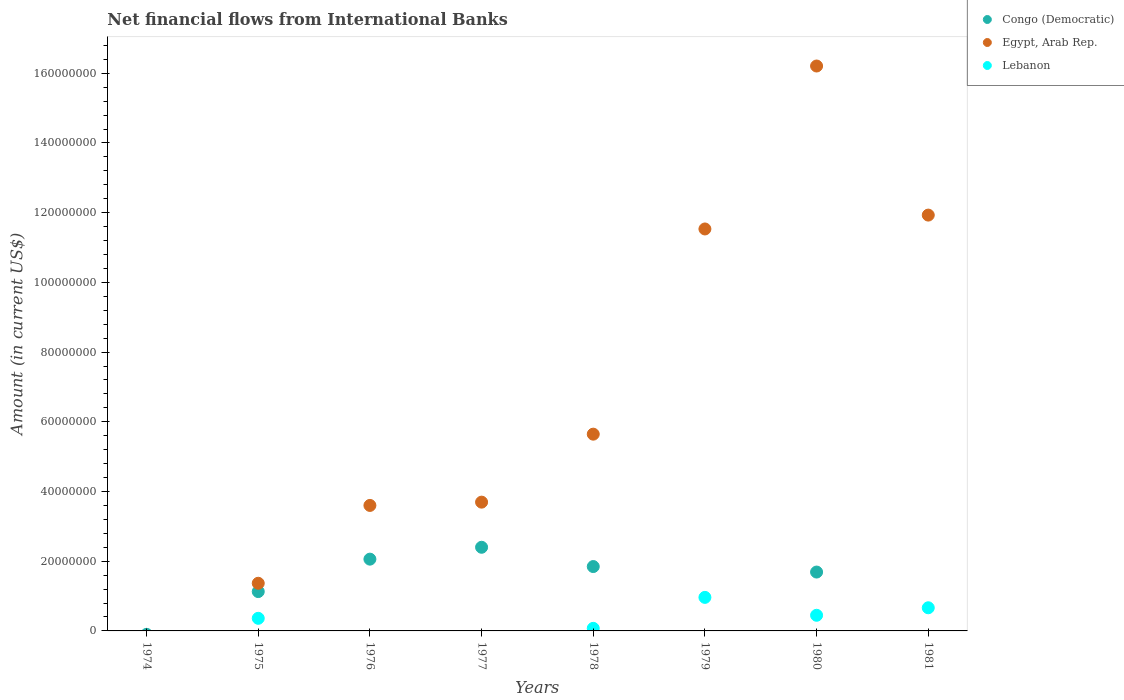Is the number of dotlines equal to the number of legend labels?
Give a very brief answer. No. What is the net financial aid flows in Egypt, Arab Rep. in 1980?
Make the answer very short. 1.62e+08. Across all years, what is the maximum net financial aid flows in Congo (Democratic)?
Make the answer very short. 2.40e+07. In which year was the net financial aid flows in Lebanon maximum?
Provide a short and direct response. 1979. What is the total net financial aid flows in Lebanon in the graph?
Make the answer very short. 2.51e+07. What is the difference between the net financial aid flows in Lebanon in 1978 and that in 1980?
Provide a short and direct response. -3.75e+06. What is the difference between the net financial aid flows in Lebanon in 1975 and the net financial aid flows in Egypt, Arab Rep. in 1974?
Keep it short and to the point. 3.62e+06. What is the average net financial aid flows in Congo (Democratic) per year?
Keep it short and to the point. 1.14e+07. In the year 1978, what is the difference between the net financial aid flows in Lebanon and net financial aid flows in Congo (Democratic)?
Your answer should be compact. -1.77e+07. What is the ratio of the net financial aid flows in Egypt, Arab Rep. in 1976 to that in 1981?
Your answer should be compact. 0.3. Is the net financial aid flows in Egypt, Arab Rep. in 1976 less than that in 1981?
Provide a succinct answer. Yes. Is the difference between the net financial aid flows in Lebanon in 1975 and 1980 greater than the difference between the net financial aid flows in Congo (Democratic) in 1975 and 1980?
Give a very brief answer. Yes. What is the difference between the highest and the second highest net financial aid flows in Egypt, Arab Rep.?
Your answer should be very brief. 4.28e+07. What is the difference between the highest and the lowest net financial aid flows in Congo (Democratic)?
Make the answer very short. 2.40e+07. Is the sum of the net financial aid flows in Congo (Democratic) in 1976 and 1977 greater than the maximum net financial aid flows in Lebanon across all years?
Ensure brevity in your answer.  Yes. How many years are there in the graph?
Keep it short and to the point. 8. Does the graph contain any zero values?
Keep it short and to the point. Yes. Does the graph contain grids?
Provide a succinct answer. No. How many legend labels are there?
Keep it short and to the point. 3. What is the title of the graph?
Offer a terse response. Net financial flows from International Banks. Does "Latin America(developing only)" appear as one of the legend labels in the graph?
Provide a succinct answer. No. What is the label or title of the X-axis?
Offer a very short reply. Years. What is the label or title of the Y-axis?
Offer a very short reply. Amount (in current US$). What is the Amount (in current US$) in Congo (Democratic) in 1974?
Give a very brief answer. 0. What is the Amount (in current US$) in Egypt, Arab Rep. in 1974?
Make the answer very short. 0. What is the Amount (in current US$) of Congo (Democratic) in 1975?
Your answer should be compact. 1.13e+07. What is the Amount (in current US$) of Egypt, Arab Rep. in 1975?
Make the answer very short. 1.37e+07. What is the Amount (in current US$) in Lebanon in 1975?
Give a very brief answer. 3.62e+06. What is the Amount (in current US$) of Congo (Democratic) in 1976?
Your answer should be compact. 2.06e+07. What is the Amount (in current US$) of Egypt, Arab Rep. in 1976?
Provide a succinct answer. 3.60e+07. What is the Amount (in current US$) in Congo (Democratic) in 1977?
Provide a short and direct response. 2.40e+07. What is the Amount (in current US$) in Egypt, Arab Rep. in 1977?
Give a very brief answer. 3.69e+07. What is the Amount (in current US$) in Lebanon in 1977?
Offer a terse response. 0. What is the Amount (in current US$) in Congo (Democratic) in 1978?
Offer a very short reply. 1.85e+07. What is the Amount (in current US$) in Egypt, Arab Rep. in 1978?
Give a very brief answer. 5.65e+07. What is the Amount (in current US$) of Lebanon in 1978?
Your answer should be compact. 7.38e+05. What is the Amount (in current US$) in Congo (Democratic) in 1979?
Offer a terse response. 0. What is the Amount (in current US$) in Egypt, Arab Rep. in 1979?
Offer a terse response. 1.15e+08. What is the Amount (in current US$) in Lebanon in 1979?
Offer a terse response. 9.62e+06. What is the Amount (in current US$) in Congo (Democratic) in 1980?
Keep it short and to the point. 1.69e+07. What is the Amount (in current US$) in Egypt, Arab Rep. in 1980?
Your response must be concise. 1.62e+08. What is the Amount (in current US$) in Lebanon in 1980?
Offer a terse response. 4.49e+06. What is the Amount (in current US$) of Egypt, Arab Rep. in 1981?
Ensure brevity in your answer.  1.19e+08. What is the Amount (in current US$) of Lebanon in 1981?
Provide a short and direct response. 6.64e+06. Across all years, what is the maximum Amount (in current US$) in Congo (Democratic)?
Keep it short and to the point. 2.40e+07. Across all years, what is the maximum Amount (in current US$) in Egypt, Arab Rep.?
Give a very brief answer. 1.62e+08. Across all years, what is the maximum Amount (in current US$) of Lebanon?
Offer a terse response. 9.62e+06. Across all years, what is the minimum Amount (in current US$) of Congo (Democratic)?
Provide a succinct answer. 0. Across all years, what is the minimum Amount (in current US$) of Lebanon?
Give a very brief answer. 0. What is the total Amount (in current US$) in Congo (Democratic) in the graph?
Your answer should be very brief. 9.12e+07. What is the total Amount (in current US$) in Egypt, Arab Rep. in the graph?
Your response must be concise. 5.40e+08. What is the total Amount (in current US$) in Lebanon in the graph?
Your answer should be compact. 2.51e+07. What is the difference between the Amount (in current US$) in Congo (Democratic) in 1975 and that in 1976?
Your answer should be very brief. -9.30e+06. What is the difference between the Amount (in current US$) of Egypt, Arab Rep. in 1975 and that in 1976?
Ensure brevity in your answer.  -2.23e+07. What is the difference between the Amount (in current US$) of Congo (Democratic) in 1975 and that in 1977?
Give a very brief answer. -1.27e+07. What is the difference between the Amount (in current US$) of Egypt, Arab Rep. in 1975 and that in 1977?
Give a very brief answer. -2.33e+07. What is the difference between the Amount (in current US$) in Congo (Democratic) in 1975 and that in 1978?
Offer a terse response. -7.18e+06. What is the difference between the Amount (in current US$) in Egypt, Arab Rep. in 1975 and that in 1978?
Provide a short and direct response. -4.28e+07. What is the difference between the Amount (in current US$) in Lebanon in 1975 and that in 1978?
Keep it short and to the point. 2.88e+06. What is the difference between the Amount (in current US$) of Egypt, Arab Rep. in 1975 and that in 1979?
Provide a short and direct response. -1.02e+08. What is the difference between the Amount (in current US$) in Lebanon in 1975 and that in 1979?
Ensure brevity in your answer.  -6.00e+06. What is the difference between the Amount (in current US$) of Congo (Democratic) in 1975 and that in 1980?
Offer a terse response. -5.60e+06. What is the difference between the Amount (in current US$) of Egypt, Arab Rep. in 1975 and that in 1980?
Make the answer very short. -1.48e+08. What is the difference between the Amount (in current US$) of Lebanon in 1975 and that in 1980?
Your response must be concise. -8.71e+05. What is the difference between the Amount (in current US$) of Egypt, Arab Rep. in 1975 and that in 1981?
Offer a terse response. -1.06e+08. What is the difference between the Amount (in current US$) of Lebanon in 1975 and that in 1981?
Provide a succinct answer. -3.02e+06. What is the difference between the Amount (in current US$) of Congo (Democratic) in 1976 and that in 1977?
Your answer should be compact. -3.41e+06. What is the difference between the Amount (in current US$) of Egypt, Arab Rep. in 1976 and that in 1977?
Offer a very short reply. -9.43e+05. What is the difference between the Amount (in current US$) in Congo (Democratic) in 1976 and that in 1978?
Make the answer very short. 2.12e+06. What is the difference between the Amount (in current US$) in Egypt, Arab Rep. in 1976 and that in 1978?
Keep it short and to the point. -2.04e+07. What is the difference between the Amount (in current US$) of Egypt, Arab Rep. in 1976 and that in 1979?
Your answer should be very brief. -7.93e+07. What is the difference between the Amount (in current US$) in Congo (Democratic) in 1976 and that in 1980?
Offer a terse response. 3.70e+06. What is the difference between the Amount (in current US$) of Egypt, Arab Rep. in 1976 and that in 1980?
Provide a short and direct response. -1.26e+08. What is the difference between the Amount (in current US$) of Egypt, Arab Rep. in 1976 and that in 1981?
Offer a terse response. -8.33e+07. What is the difference between the Amount (in current US$) in Congo (Democratic) in 1977 and that in 1978?
Your answer should be compact. 5.53e+06. What is the difference between the Amount (in current US$) in Egypt, Arab Rep. in 1977 and that in 1978?
Give a very brief answer. -1.95e+07. What is the difference between the Amount (in current US$) in Egypt, Arab Rep. in 1977 and that in 1979?
Your response must be concise. -7.84e+07. What is the difference between the Amount (in current US$) of Congo (Democratic) in 1977 and that in 1980?
Offer a terse response. 7.11e+06. What is the difference between the Amount (in current US$) of Egypt, Arab Rep. in 1977 and that in 1980?
Give a very brief answer. -1.25e+08. What is the difference between the Amount (in current US$) in Egypt, Arab Rep. in 1977 and that in 1981?
Offer a terse response. -8.24e+07. What is the difference between the Amount (in current US$) in Egypt, Arab Rep. in 1978 and that in 1979?
Ensure brevity in your answer.  -5.89e+07. What is the difference between the Amount (in current US$) of Lebanon in 1978 and that in 1979?
Your answer should be compact. -8.88e+06. What is the difference between the Amount (in current US$) of Congo (Democratic) in 1978 and that in 1980?
Provide a short and direct response. 1.58e+06. What is the difference between the Amount (in current US$) of Egypt, Arab Rep. in 1978 and that in 1980?
Your response must be concise. -1.06e+08. What is the difference between the Amount (in current US$) of Lebanon in 1978 and that in 1980?
Keep it short and to the point. -3.75e+06. What is the difference between the Amount (in current US$) of Egypt, Arab Rep. in 1978 and that in 1981?
Provide a short and direct response. -6.29e+07. What is the difference between the Amount (in current US$) of Lebanon in 1978 and that in 1981?
Offer a terse response. -5.90e+06. What is the difference between the Amount (in current US$) of Egypt, Arab Rep. in 1979 and that in 1980?
Provide a short and direct response. -4.68e+07. What is the difference between the Amount (in current US$) in Lebanon in 1979 and that in 1980?
Your answer should be compact. 5.13e+06. What is the difference between the Amount (in current US$) in Egypt, Arab Rep. in 1979 and that in 1981?
Keep it short and to the point. -3.98e+06. What is the difference between the Amount (in current US$) in Lebanon in 1979 and that in 1981?
Make the answer very short. 2.98e+06. What is the difference between the Amount (in current US$) of Egypt, Arab Rep. in 1980 and that in 1981?
Make the answer very short. 4.28e+07. What is the difference between the Amount (in current US$) in Lebanon in 1980 and that in 1981?
Offer a terse response. -2.15e+06. What is the difference between the Amount (in current US$) in Congo (Democratic) in 1975 and the Amount (in current US$) in Egypt, Arab Rep. in 1976?
Your answer should be very brief. -2.47e+07. What is the difference between the Amount (in current US$) in Congo (Democratic) in 1975 and the Amount (in current US$) in Egypt, Arab Rep. in 1977?
Ensure brevity in your answer.  -2.57e+07. What is the difference between the Amount (in current US$) in Congo (Democratic) in 1975 and the Amount (in current US$) in Egypt, Arab Rep. in 1978?
Offer a terse response. -4.52e+07. What is the difference between the Amount (in current US$) in Congo (Democratic) in 1975 and the Amount (in current US$) in Lebanon in 1978?
Provide a succinct answer. 1.05e+07. What is the difference between the Amount (in current US$) of Egypt, Arab Rep. in 1975 and the Amount (in current US$) of Lebanon in 1978?
Provide a succinct answer. 1.29e+07. What is the difference between the Amount (in current US$) of Congo (Democratic) in 1975 and the Amount (in current US$) of Egypt, Arab Rep. in 1979?
Your response must be concise. -1.04e+08. What is the difference between the Amount (in current US$) in Congo (Democratic) in 1975 and the Amount (in current US$) in Lebanon in 1979?
Your answer should be very brief. 1.66e+06. What is the difference between the Amount (in current US$) in Egypt, Arab Rep. in 1975 and the Amount (in current US$) in Lebanon in 1979?
Offer a terse response. 4.05e+06. What is the difference between the Amount (in current US$) in Congo (Democratic) in 1975 and the Amount (in current US$) in Egypt, Arab Rep. in 1980?
Ensure brevity in your answer.  -1.51e+08. What is the difference between the Amount (in current US$) in Congo (Democratic) in 1975 and the Amount (in current US$) in Lebanon in 1980?
Ensure brevity in your answer.  6.80e+06. What is the difference between the Amount (in current US$) of Egypt, Arab Rep. in 1975 and the Amount (in current US$) of Lebanon in 1980?
Keep it short and to the point. 9.18e+06. What is the difference between the Amount (in current US$) in Congo (Democratic) in 1975 and the Amount (in current US$) in Egypt, Arab Rep. in 1981?
Offer a terse response. -1.08e+08. What is the difference between the Amount (in current US$) in Congo (Democratic) in 1975 and the Amount (in current US$) in Lebanon in 1981?
Your answer should be very brief. 4.64e+06. What is the difference between the Amount (in current US$) in Egypt, Arab Rep. in 1975 and the Amount (in current US$) in Lebanon in 1981?
Your answer should be very brief. 7.03e+06. What is the difference between the Amount (in current US$) of Congo (Democratic) in 1976 and the Amount (in current US$) of Egypt, Arab Rep. in 1977?
Ensure brevity in your answer.  -1.64e+07. What is the difference between the Amount (in current US$) of Congo (Democratic) in 1976 and the Amount (in current US$) of Egypt, Arab Rep. in 1978?
Keep it short and to the point. -3.59e+07. What is the difference between the Amount (in current US$) of Congo (Democratic) in 1976 and the Amount (in current US$) of Lebanon in 1978?
Give a very brief answer. 1.99e+07. What is the difference between the Amount (in current US$) in Egypt, Arab Rep. in 1976 and the Amount (in current US$) in Lebanon in 1978?
Keep it short and to the point. 3.53e+07. What is the difference between the Amount (in current US$) of Congo (Democratic) in 1976 and the Amount (in current US$) of Egypt, Arab Rep. in 1979?
Keep it short and to the point. -9.47e+07. What is the difference between the Amount (in current US$) of Congo (Democratic) in 1976 and the Amount (in current US$) of Lebanon in 1979?
Ensure brevity in your answer.  1.10e+07. What is the difference between the Amount (in current US$) of Egypt, Arab Rep. in 1976 and the Amount (in current US$) of Lebanon in 1979?
Offer a very short reply. 2.64e+07. What is the difference between the Amount (in current US$) in Congo (Democratic) in 1976 and the Amount (in current US$) in Egypt, Arab Rep. in 1980?
Provide a succinct answer. -1.41e+08. What is the difference between the Amount (in current US$) in Congo (Democratic) in 1976 and the Amount (in current US$) in Lebanon in 1980?
Make the answer very short. 1.61e+07. What is the difference between the Amount (in current US$) of Egypt, Arab Rep. in 1976 and the Amount (in current US$) of Lebanon in 1980?
Make the answer very short. 3.15e+07. What is the difference between the Amount (in current US$) in Congo (Democratic) in 1976 and the Amount (in current US$) in Egypt, Arab Rep. in 1981?
Give a very brief answer. -9.87e+07. What is the difference between the Amount (in current US$) of Congo (Democratic) in 1976 and the Amount (in current US$) of Lebanon in 1981?
Provide a short and direct response. 1.40e+07. What is the difference between the Amount (in current US$) in Egypt, Arab Rep. in 1976 and the Amount (in current US$) in Lebanon in 1981?
Provide a short and direct response. 2.94e+07. What is the difference between the Amount (in current US$) of Congo (Democratic) in 1977 and the Amount (in current US$) of Egypt, Arab Rep. in 1978?
Offer a terse response. -3.25e+07. What is the difference between the Amount (in current US$) of Congo (Democratic) in 1977 and the Amount (in current US$) of Lebanon in 1978?
Keep it short and to the point. 2.33e+07. What is the difference between the Amount (in current US$) in Egypt, Arab Rep. in 1977 and the Amount (in current US$) in Lebanon in 1978?
Give a very brief answer. 3.62e+07. What is the difference between the Amount (in current US$) of Congo (Democratic) in 1977 and the Amount (in current US$) of Egypt, Arab Rep. in 1979?
Make the answer very short. -9.13e+07. What is the difference between the Amount (in current US$) of Congo (Democratic) in 1977 and the Amount (in current US$) of Lebanon in 1979?
Your answer should be compact. 1.44e+07. What is the difference between the Amount (in current US$) in Egypt, Arab Rep. in 1977 and the Amount (in current US$) in Lebanon in 1979?
Your response must be concise. 2.73e+07. What is the difference between the Amount (in current US$) in Congo (Democratic) in 1977 and the Amount (in current US$) in Egypt, Arab Rep. in 1980?
Provide a short and direct response. -1.38e+08. What is the difference between the Amount (in current US$) in Congo (Democratic) in 1977 and the Amount (in current US$) in Lebanon in 1980?
Make the answer very short. 1.95e+07. What is the difference between the Amount (in current US$) of Egypt, Arab Rep. in 1977 and the Amount (in current US$) of Lebanon in 1980?
Keep it short and to the point. 3.25e+07. What is the difference between the Amount (in current US$) of Congo (Democratic) in 1977 and the Amount (in current US$) of Egypt, Arab Rep. in 1981?
Offer a very short reply. -9.53e+07. What is the difference between the Amount (in current US$) of Congo (Democratic) in 1977 and the Amount (in current US$) of Lebanon in 1981?
Your response must be concise. 1.74e+07. What is the difference between the Amount (in current US$) of Egypt, Arab Rep. in 1977 and the Amount (in current US$) of Lebanon in 1981?
Offer a terse response. 3.03e+07. What is the difference between the Amount (in current US$) in Congo (Democratic) in 1978 and the Amount (in current US$) in Egypt, Arab Rep. in 1979?
Provide a succinct answer. -9.69e+07. What is the difference between the Amount (in current US$) of Congo (Democratic) in 1978 and the Amount (in current US$) of Lebanon in 1979?
Ensure brevity in your answer.  8.84e+06. What is the difference between the Amount (in current US$) of Egypt, Arab Rep. in 1978 and the Amount (in current US$) of Lebanon in 1979?
Your response must be concise. 4.68e+07. What is the difference between the Amount (in current US$) of Congo (Democratic) in 1978 and the Amount (in current US$) of Egypt, Arab Rep. in 1980?
Ensure brevity in your answer.  -1.44e+08. What is the difference between the Amount (in current US$) in Congo (Democratic) in 1978 and the Amount (in current US$) in Lebanon in 1980?
Your answer should be very brief. 1.40e+07. What is the difference between the Amount (in current US$) of Egypt, Arab Rep. in 1978 and the Amount (in current US$) of Lebanon in 1980?
Ensure brevity in your answer.  5.20e+07. What is the difference between the Amount (in current US$) of Congo (Democratic) in 1978 and the Amount (in current US$) of Egypt, Arab Rep. in 1981?
Your answer should be compact. -1.01e+08. What is the difference between the Amount (in current US$) in Congo (Democratic) in 1978 and the Amount (in current US$) in Lebanon in 1981?
Your response must be concise. 1.18e+07. What is the difference between the Amount (in current US$) of Egypt, Arab Rep. in 1978 and the Amount (in current US$) of Lebanon in 1981?
Your response must be concise. 4.98e+07. What is the difference between the Amount (in current US$) of Egypt, Arab Rep. in 1979 and the Amount (in current US$) of Lebanon in 1980?
Offer a very short reply. 1.11e+08. What is the difference between the Amount (in current US$) in Egypt, Arab Rep. in 1979 and the Amount (in current US$) in Lebanon in 1981?
Provide a short and direct response. 1.09e+08. What is the difference between the Amount (in current US$) of Congo (Democratic) in 1980 and the Amount (in current US$) of Egypt, Arab Rep. in 1981?
Ensure brevity in your answer.  -1.02e+08. What is the difference between the Amount (in current US$) in Congo (Democratic) in 1980 and the Amount (in current US$) in Lebanon in 1981?
Your answer should be very brief. 1.02e+07. What is the difference between the Amount (in current US$) of Egypt, Arab Rep. in 1980 and the Amount (in current US$) of Lebanon in 1981?
Offer a terse response. 1.55e+08. What is the average Amount (in current US$) in Congo (Democratic) per year?
Offer a very short reply. 1.14e+07. What is the average Amount (in current US$) in Egypt, Arab Rep. per year?
Provide a short and direct response. 6.75e+07. What is the average Amount (in current US$) in Lebanon per year?
Offer a very short reply. 3.14e+06. In the year 1975, what is the difference between the Amount (in current US$) of Congo (Democratic) and Amount (in current US$) of Egypt, Arab Rep.?
Your answer should be very brief. -2.38e+06. In the year 1975, what is the difference between the Amount (in current US$) in Congo (Democratic) and Amount (in current US$) in Lebanon?
Provide a succinct answer. 7.67e+06. In the year 1975, what is the difference between the Amount (in current US$) of Egypt, Arab Rep. and Amount (in current US$) of Lebanon?
Make the answer very short. 1.01e+07. In the year 1976, what is the difference between the Amount (in current US$) of Congo (Democratic) and Amount (in current US$) of Egypt, Arab Rep.?
Offer a very short reply. -1.54e+07. In the year 1977, what is the difference between the Amount (in current US$) of Congo (Democratic) and Amount (in current US$) of Egypt, Arab Rep.?
Offer a terse response. -1.29e+07. In the year 1978, what is the difference between the Amount (in current US$) in Congo (Democratic) and Amount (in current US$) in Egypt, Arab Rep.?
Your answer should be very brief. -3.80e+07. In the year 1978, what is the difference between the Amount (in current US$) in Congo (Democratic) and Amount (in current US$) in Lebanon?
Offer a terse response. 1.77e+07. In the year 1978, what is the difference between the Amount (in current US$) of Egypt, Arab Rep. and Amount (in current US$) of Lebanon?
Your response must be concise. 5.57e+07. In the year 1979, what is the difference between the Amount (in current US$) of Egypt, Arab Rep. and Amount (in current US$) of Lebanon?
Your response must be concise. 1.06e+08. In the year 1980, what is the difference between the Amount (in current US$) in Congo (Democratic) and Amount (in current US$) in Egypt, Arab Rep.?
Keep it short and to the point. -1.45e+08. In the year 1980, what is the difference between the Amount (in current US$) of Congo (Democratic) and Amount (in current US$) of Lebanon?
Your response must be concise. 1.24e+07. In the year 1980, what is the difference between the Amount (in current US$) in Egypt, Arab Rep. and Amount (in current US$) in Lebanon?
Ensure brevity in your answer.  1.58e+08. In the year 1981, what is the difference between the Amount (in current US$) in Egypt, Arab Rep. and Amount (in current US$) in Lebanon?
Make the answer very short. 1.13e+08. What is the ratio of the Amount (in current US$) in Congo (Democratic) in 1975 to that in 1976?
Ensure brevity in your answer.  0.55. What is the ratio of the Amount (in current US$) in Egypt, Arab Rep. in 1975 to that in 1976?
Your response must be concise. 0.38. What is the ratio of the Amount (in current US$) of Congo (Democratic) in 1975 to that in 1977?
Provide a succinct answer. 0.47. What is the ratio of the Amount (in current US$) in Egypt, Arab Rep. in 1975 to that in 1977?
Give a very brief answer. 0.37. What is the ratio of the Amount (in current US$) of Congo (Democratic) in 1975 to that in 1978?
Your answer should be very brief. 0.61. What is the ratio of the Amount (in current US$) of Egypt, Arab Rep. in 1975 to that in 1978?
Provide a short and direct response. 0.24. What is the ratio of the Amount (in current US$) of Lebanon in 1975 to that in 1978?
Offer a terse response. 4.9. What is the ratio of the Amount (in current US$) in Egypt, Arab Rep. in 1975 to that in 1979?
Ensure brevity in your answer.  0.12. What is the ratio of the Amount (in current US$) in Lebanon in 1975 to that in 1979?
Make the answer very short. 0.38. What is the ratio of the Amount (in current US$) of Congo (Democratic) in 1975 to that in 1980?
Your response must be concise. 0.67. What is the ratio of the Amount (in current US$) in Egypt, Arab Rep. in 1975 to that in 1980?
Keep it short and to the point. 0.08. What is the ratio of the Amount (in current US$) in Lebanon in 1975 to that in 1980?
Offer a very short reply. 0.81. What is the ratio of the Amount (in current US$) in Egypt, Arab Rep. in 1975 to that in 1981?
Ensure brevity in your answer.  0.11. What is the ratio of the Amount (in current US$) of Lebanon in 1975 to that in 1981?
Offer a very short reply. 0.54. What is the ratio of the Amount (in current US$) in Congo (Democratic) in 1976 to that in 1977?
Your response must be concise. 0.86. What is the ratio of the Amount (in current US$) in Egypt, Arab Rep. in 1976 to that in 1977?
Ensure brevity in your answer.  0.97. What is the ratio of the Amount (in current US$) in Congo (Democratic) in 1976 to that in 1978?
Make the answer very short. 1.11. What is the ratio of the Amount (in current US$) of Egypt, Arab Rep. in 1976 to that in 1978?
Make the answer very short. 0.64. What is the ratio of the Amount (in current US$) in Egypt, Arab Rep. in 1976 to that in 1979?
Make the answer very short. 0.31. What is the ratio of the Amount (in current US$) of Congo (Democratic) in 1976 to that in 1980?
Provide a short and direct response. 1.22. What is the ratio of the Amount (in current US$) in Egypt, Arab Rep. in 1976 to that in 1980?
Offer a very short reply. 0.22. What is the ratio of the Amount (in current US$) of Egypt, Arab Rep. in 1976 to that in 1981?
Ensure brevity in your answer.  0.3. What is the ratio of the Amount (in current US$) of Congo (Democratic) in 1977 to that in 1978?
Provide a succinct answer. 1.3. What is the ratio of the Amount (in current US$) of Egypt, Arab Rep. in 1977 to that in 1978?
Your response must be concise. 0.65. What is the ratio of the Amount (in current US$) of Egypt, Arab Rep. in 1977 to that in 1979?
Provide a succinct answer. 0.32. What is the ratio of the Amount (in current US$) of Congo (Democratic) in 1977 to that in 1980?
Provide a short and direct response. 1.42. What is the ratio of the Amount (in current US$) in Egypt, Arab Rep. in 1977 to that in 1980?
Give a very brief answer. 0.23. What is the ratio of the Amount (in current US$) of Egypt, Arab Rep. in 1977 to that in 1981?
Make the answer very short. 0.31. What is the ratio of the Amount (in current US$) of Egypt, Arab Rep. in 1978 to that in 1979?
Your answer should be very brief. 0.49. What is the ratio of the Amount (in current US$) of Lebanon in 1978 to that in 1979?
Offer a very short reply. 0.08. What is the ratio of the Amount (in current US$) of Congo (Democratic) in 1978 to that in 1980?
Keep it short and to the point. 1.09. What is the ratio of the Amount (in current US$) of Egypt, Arab Rep. in 1978 to that in 1980?
Give a very brief answer. 0.35. What is the ratio of the Amount (in current US$) in Lebanon in 1978 to that in 1980?
Provide a short and direct response. 0.16. What is the ratio of the Amount (in current US$) in Egypt, Arab Rep. in 1978 to that in 1981?
Your answer should be compact. 0.47. What is the ratio of the Amount (in current US$) of Egypt, Arab Rep. in 1979 to that in 1980?
Provide a succinct answer. 0.71. What is the ratio of the Amount (in current US$) in Lebanon in 1979 to that in 1980?
Ensure brevity in your answer.  2.14. What is the ratio of the Amount (in current US$) of Egypt, Arab Rep. in 1979 to that in 1981?
Offer a terse response. 0.97. What is the ratio of the Amount (in current US$) in Lebanon in 1979 to that in 1981?
Offer a very short reply. 1.45. What is the ratio of the Amount (in current US$) in Egypt, Arab Rep. in 1980 to that in 1981?
Keep it short and to the point. 1.36. What is the ratio of the Amount (in current US$) in Lebanon in 1980 to that in 1981?
Offer a very short reply. 0.68. What is the difference between the highest and the second highest Amount (in current US$) in Congo (Democratic)?
Your answer should be compact. 3.41e+06. What is the difference between the highest and the second highest Amount (in current US$) in Egypt, Arab Rep.?
Offer a very short reply. 4.28e+07. What is the difference between the highest and the second highest Amount (in current US$) in Lebanon?
Your answer should be very brief. 2.98e+06. What is the difference between the highest and the lowest Amount (in current US$) in Congo (Democratic)?
Provide a succinct answer. 2.40e+07. What is the difference between the highest and the lowest Amount (in current US$) in Egypt, Arab Rep.?
Offer a very short reply. 1.62e+08. What is the difference between the highest and the lowest Amount (in current US$) in Lebanon?
Offer a terse response. 9.62e+06. 